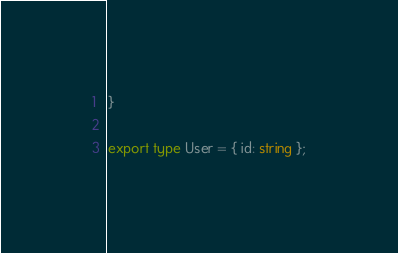<code> <loc_0><loc_0><loc_500><loc_500><_TypeScript_>}

export type User = { id: string };
</code> 